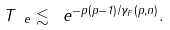<formula> <loc_0><loc_0><loc_500><loc_500>T _ { \ e } \lesssim \ e ^ { - p ( p - 1 ) / \gamma _ { F } ( p , n ) } .</formula> 